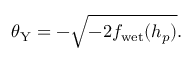Convert formula to latex. <formula><loc_0><loc_0><loc_500><loc_500>\theta _ { Y } = - \sqrt { - 2 f _ { w e t } ( h _ { p } ) } .</formula> 